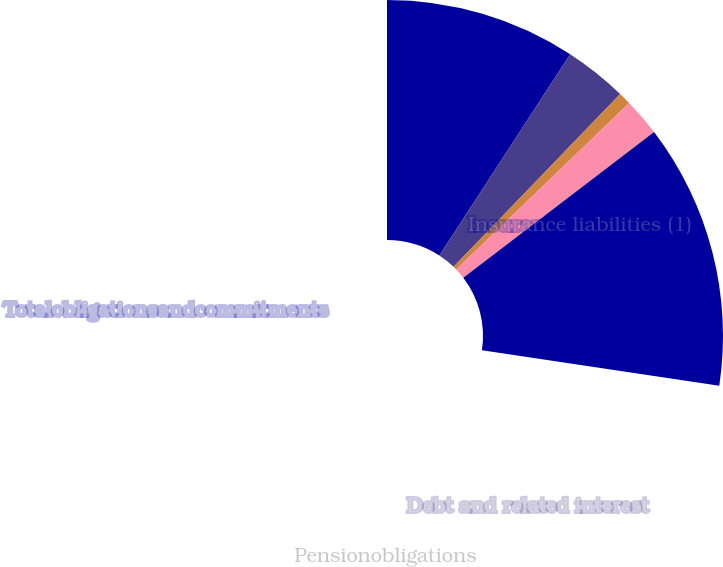<chart> <loc_0><loc_0><loc_500><loc_500><pie_chart><fcel>Insurance liabilities (1)<fcel>Debt and related interest<fcel>Operating leases<fcel>Pensionobligations<fcel>Totalobligationsandcommitments<nl><fcel>33.53%<fcel>11.07%<fcel>2.2%<fcel>6.63%<fcel>46.57%<nl></chart> 